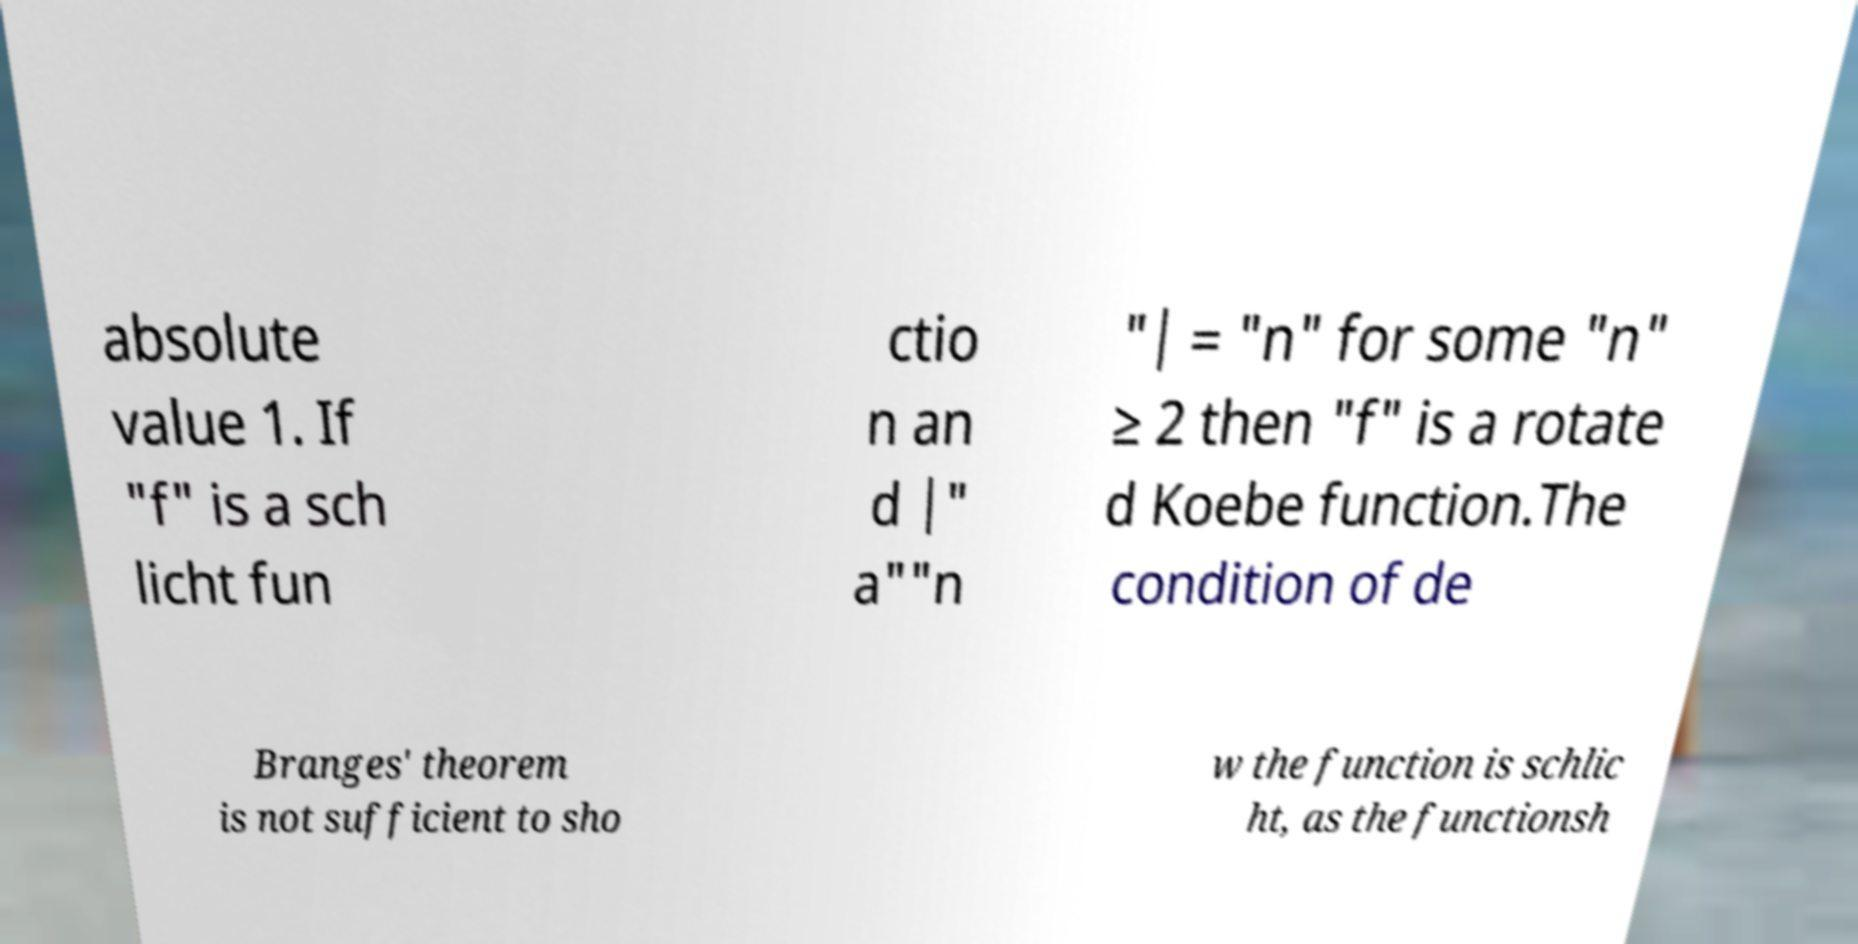Please identify and transcribe the text found in this image. absolute value 1. If "f" is a sch licht fun ctio n an d |" a""n "| = "n" for some "n" ≥ 2 then "f" is a rotate d Koebe function.The condition of de Branges' theorem is not sufficient to sho w the function is schlic ht, as the functionsh 